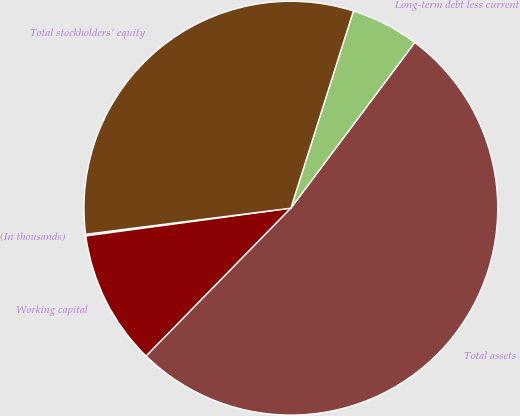Convert chart to OTSL. <chart><loc_0><loc_0><loc_500><loc_500><pie_chart><fcel>(In thousands)<fcel>Working capital<fcel>Total assets<fcel>Long-term debt less current<fcel>Total stockholders' equity<nl><fcel>0.13%<fcel>10.53%<fcel>52.1%<fcel>5.33%<fcel>31.9%<nl></chart> 